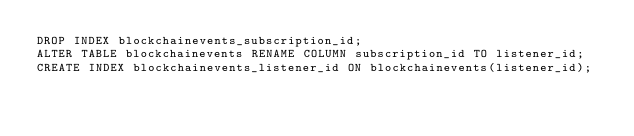Convert code to text. <code><loc_0><loc_0><loc_500><loc_500><_SQL_>DROP INDEX blockchainevents_subscription_id;
ALTER TABLE blockchainevents RENAME COLUMN subscription_id TO listener_id;
CREATE INDEX blockchainevents_listener_id ON blockchainevents(listener_id);</code> 